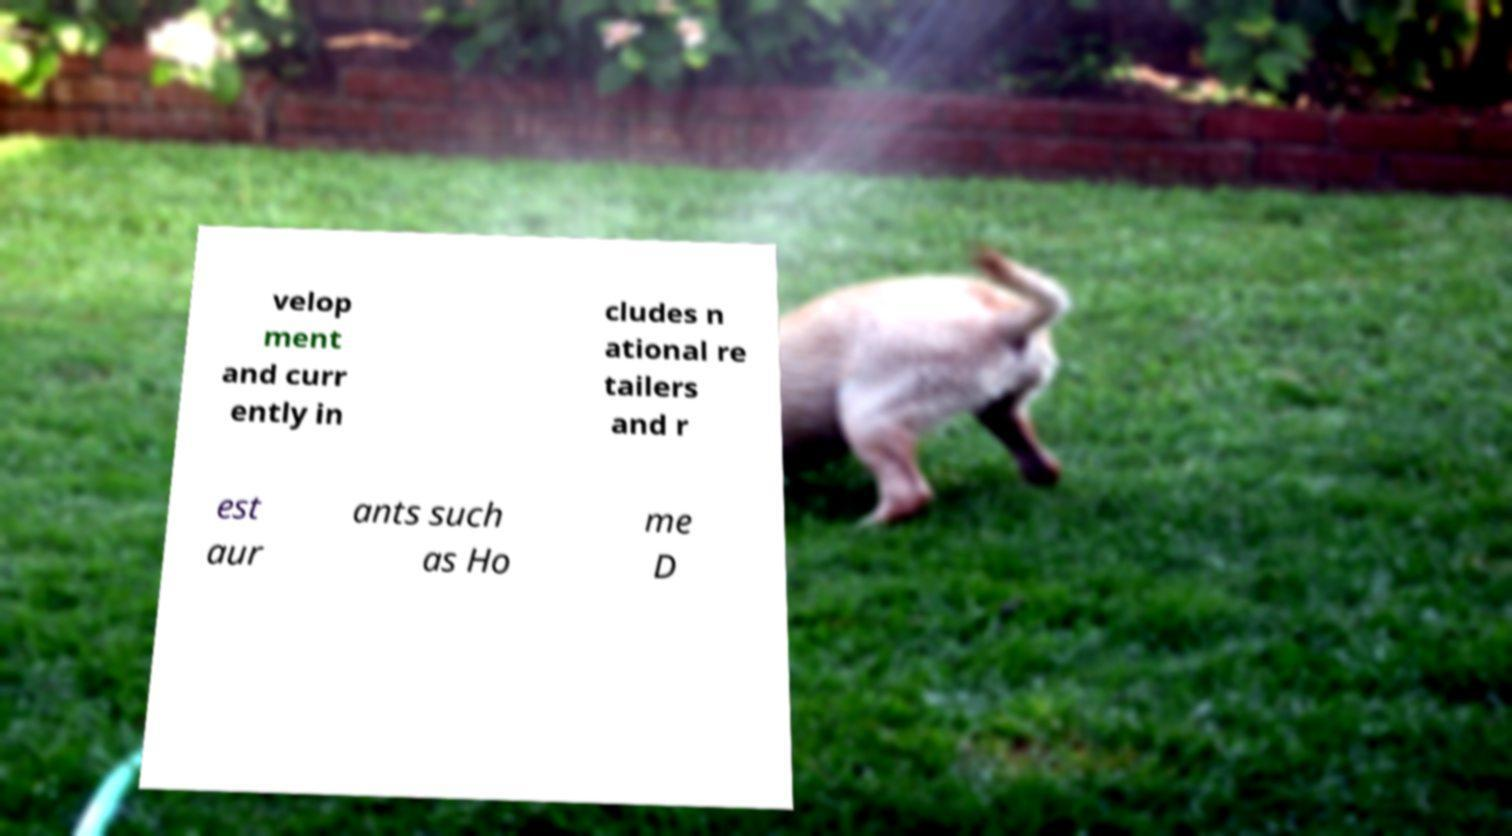Please read and relay the text visible in this image. What does it say? velop ment and curr ently in cludes n ational re tailers and r est aur ants such as Ho me D 